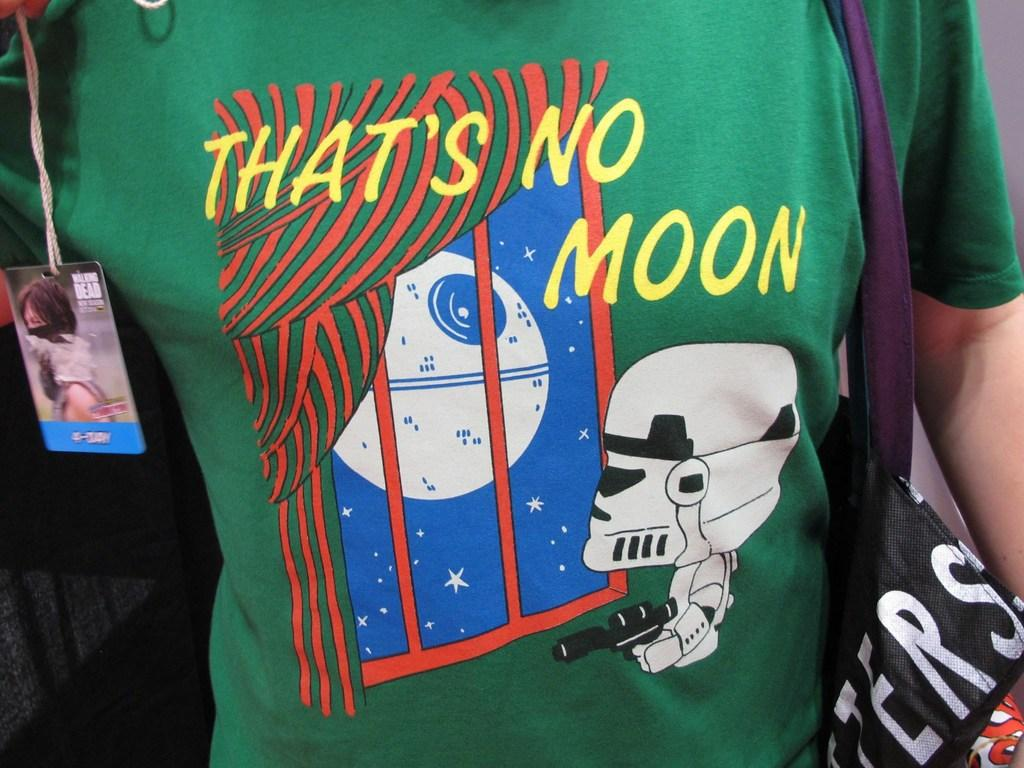<image>
Relay a brief, clear account of the picture shown. A shirt has the word moon on it and a storm trooper. 